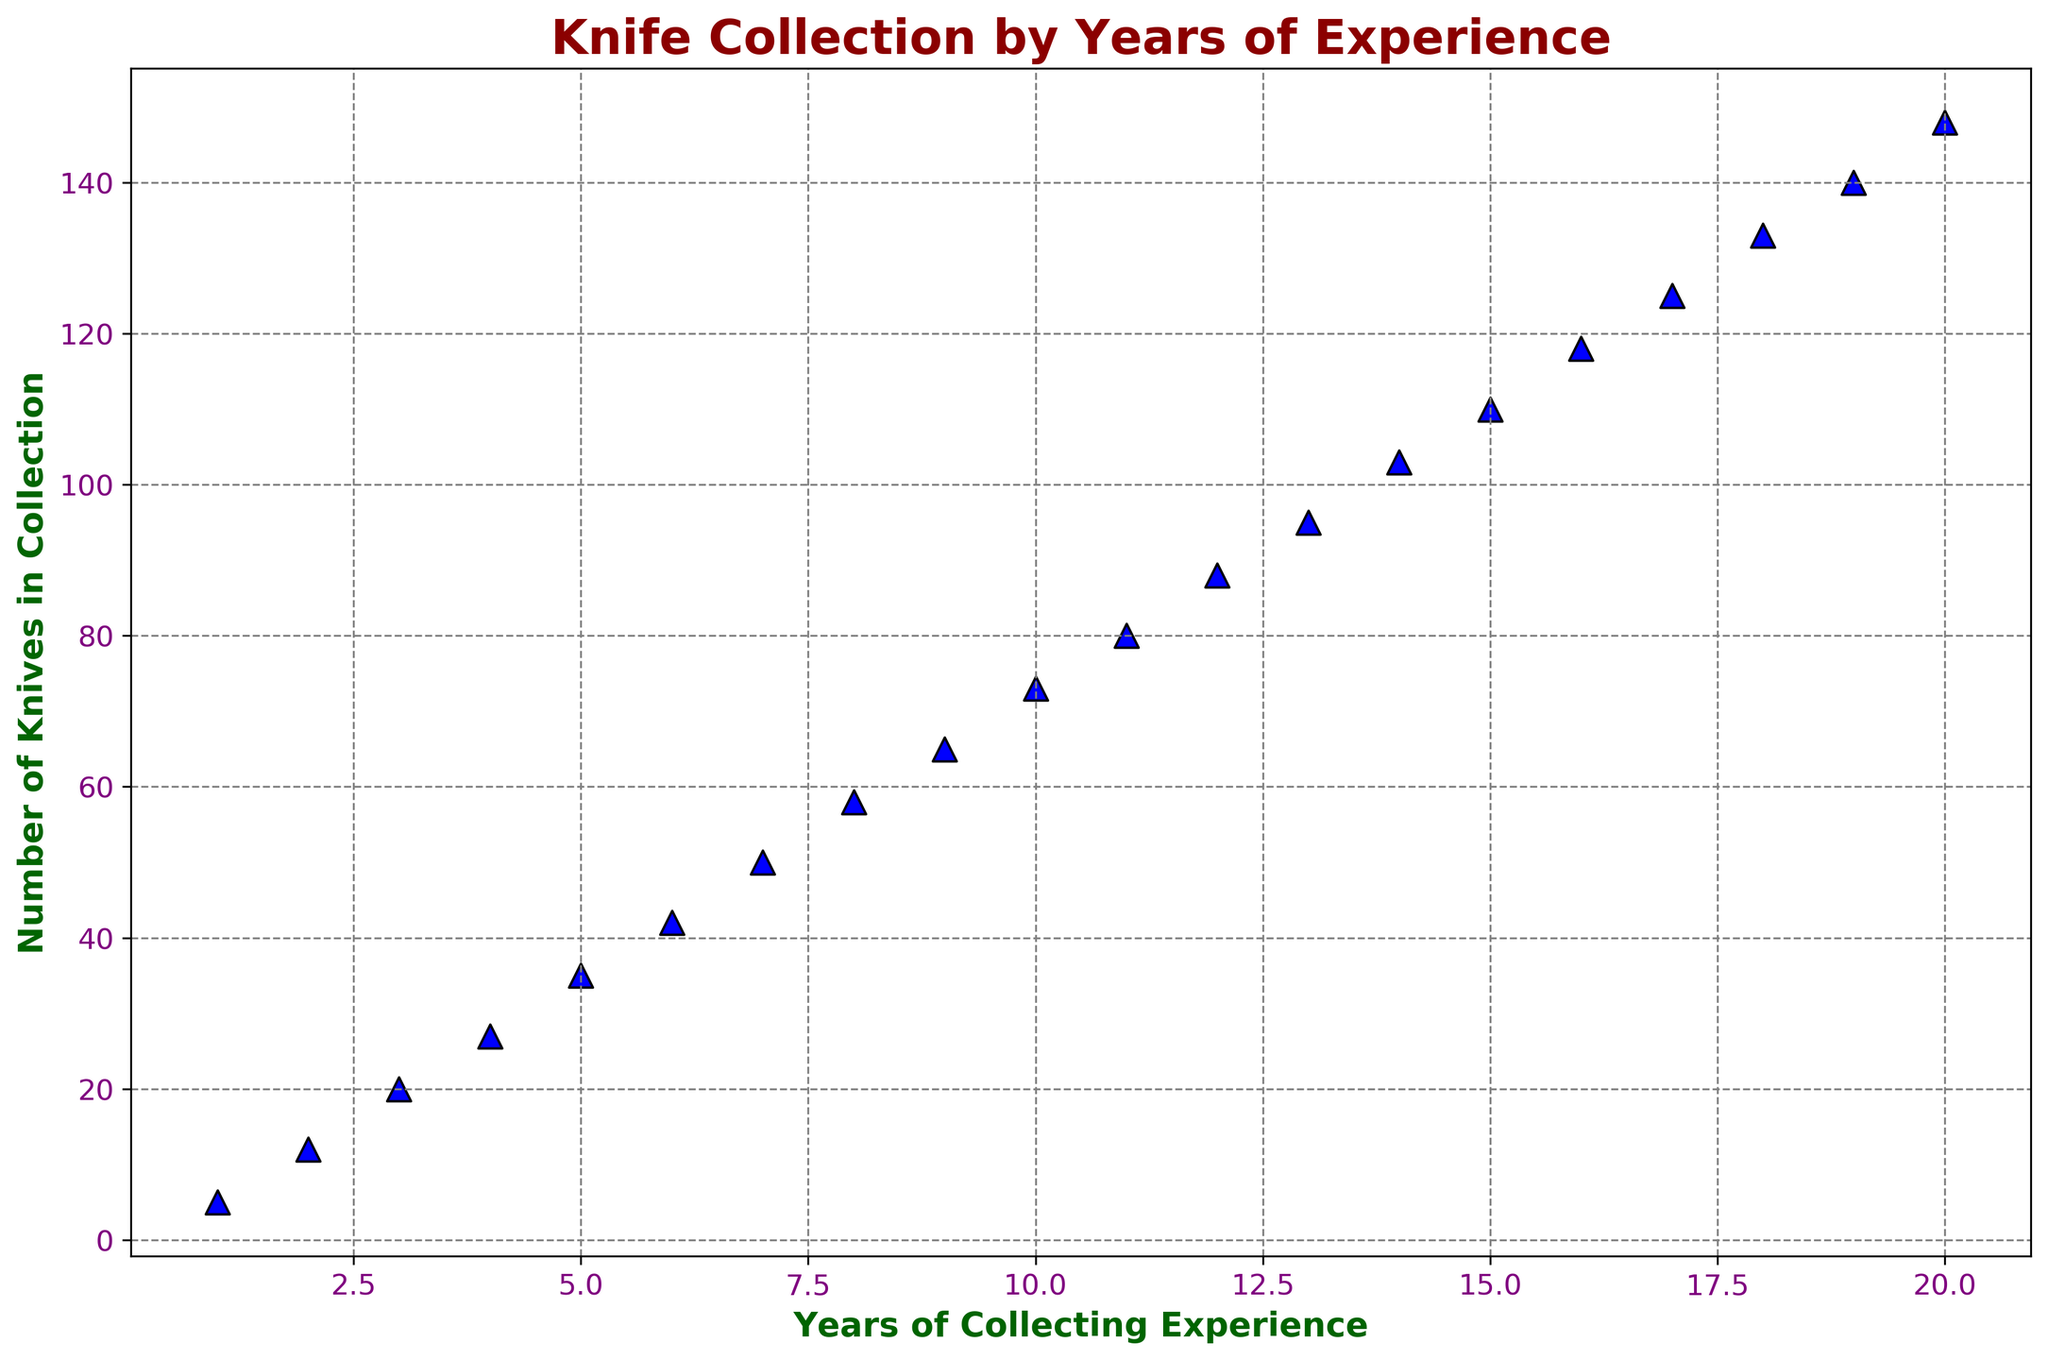What's the average number of knives collected per year? To find the average number, sum all the knives collected (5 + 12 + 20 + 27 + 35 + 42 + 50 + 58 + 65 + 73 + 80 + 88 + 95 + 103 + 110 + 118 + 125 + 133 + 140 + 148 = 1434) and divide by the number of years (20). 1434 / 20 = 71.7
Answer: 71.7 Which year shows the highest increase in the number of knives collected? By comparing the differences between consecutive years, the highest increase is from 14th to 15th year (110 to 118 knives), showing an increase of 8 knives.
Answer: 15th year After 10 years, how many knives can you predict based on the current trend? Using the plot, we observe a steady trend. By interpolating or visualizing the plot line, at 30 years the trend would likely predict around doubling from 110 knives at 15 years, so approximately 220 knives in 30 years.
Answer: Around 220 knives Between which years is the knife collection growth most consistent? By observing the scatter plot, the growth appears most consistent between year 5 and year 15 as the difference between consecutive years remains around 8-10 knives every year.
Answer: Year 5 to Year 15 How many knives are there after 8 years of collecting experience? Looking at the plot, the data point for 8 years corresponds to 58 knives.
Answer: 58 What is the visible trend of the graph in terms of collection growth over time? The scatter plot shows an increasing trend with growth rate appearing linear over time as the years of collecting experience increase, leading to a steadily increasing collection size.
Answer: Increasing trend Compare the number of knives collected in the 10th and 20th years. The data point for the 10th year shows 73 knives, and for the 20th year, it shows 148 knives. Hence, the collection nearly doubles in size over this period.
Answer: Nearly doubles What can you infer from the grid inclusion in the background of the plot? The grid helps in more accurately interpreting the values on both the axes, making it easier to visualize the number of knives for a given year of experience.
Answer: Aids in accurate visualization What color is used to denote the data points on this scatter plot? The data points are denoted by blue color, and each point has black edges making them stand out visually.
Answer: Blue with black edges Are there any years where the number of knives in the collection decreased or stagnated? Observing the scatter plot shows there are no such years; the collection consistently increases every year.
Answer: No, it consistently increases 